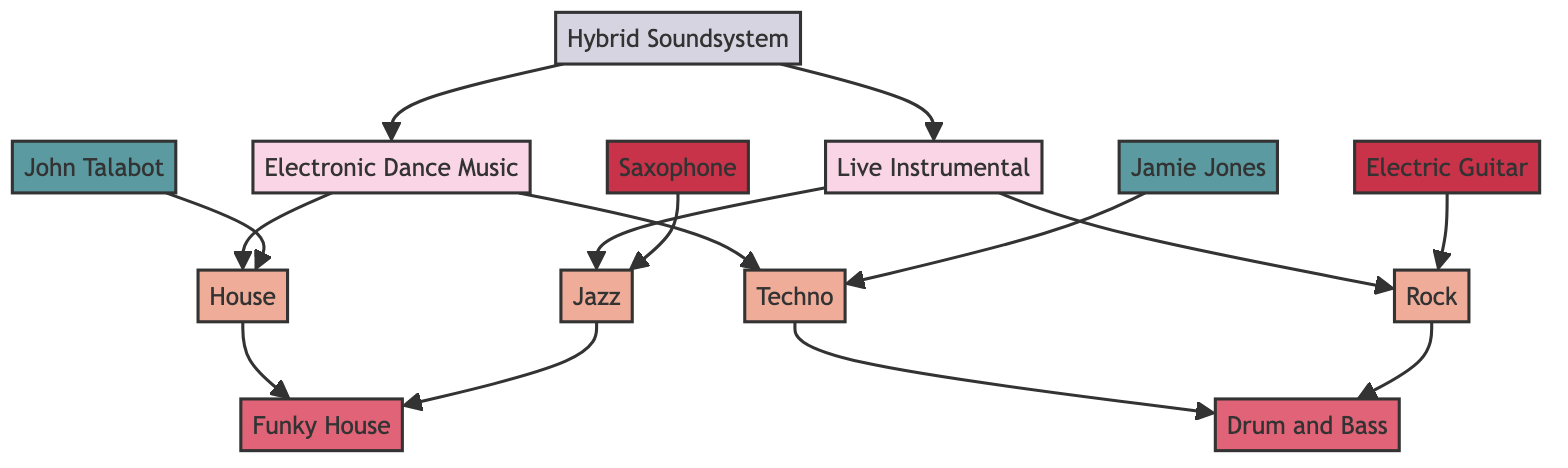What are the two main genres depicted in the diagram? The diagram displays two main genres: Electronic Dance Music and Live Instrumental. These can be seen as the root nodes at the top of the network.
Answer: Electronic Dance Music, Live Instrumental How many subgenres are connected to EDM? From the diagram, EDM has two subgenres connected to it: House and Techno. Each one is directly linked to the EDM node.
Answer: 2 What is the relationship between Live Instrumental and Rock? The diagram indicates that Live Instrumental includes Rock, which is illustrated by a directed arrow leading from Live Instrumental to Rock.
Answer: includes Which fusion genre is associated with both House and Jazz? The diagram shows that Funky House fuses with House and Jazz, as depicted by arrows connecting both genres to Funky House.
Answer: Funky House Who produces the House genre? From the diagram, the artist John Talabot is linked to House, indicating that he produces this subgenre.
Answer: John Talabot What type of techniques integrate both EDM and Live Instrumental? The diagram includes Hybrid Soundsystem, which integrates both genres, visible through the arrows connecting it to the EDM and Live Instrumental nodes.
Answer: Hybrid Soundsystem Which instrument is associated with Jazz? The Saxophone is shown associated with Jazz in the diagram, represented by a connection from the Saxophone node to the Jazz node.
Answer: Saxophone Which two subgenres fuse to create Drum and Bass? The diagram indicates that both Techno and Rock fuse to create Drum and Bass, shown by arrows from each subgenre merging into Drum and Bass.
Answer: Techno, Rock How many fusion genres are mentioned in the diagram? The diagram presents two fusion genres: Funky House and Drum and Bass, which can be counted from the respective fusion nodes.
Answer: 2 